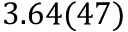Convert formula to latex. <formula><loc_0><loc_0><loc_500><loc_500>3 . 6 4 ( 4 7 )</formula> 